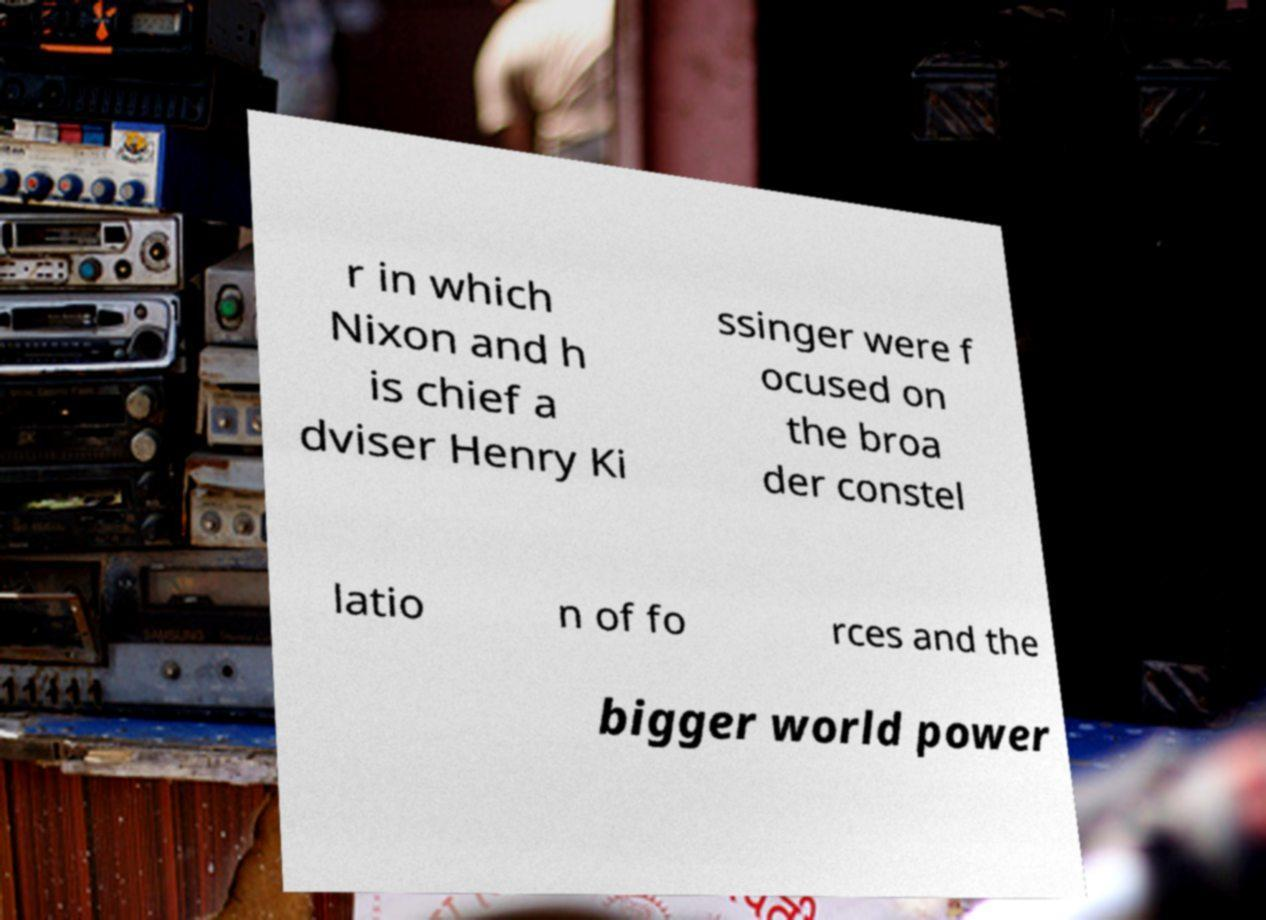Please read and relay the text visible in this image. What does it say? r in which Nixon and h is chief a dviser Henry Ki ssinger were f ocused on the broa der constel latio n of fo rces and the bigger world power 